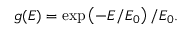Convert formula to latex. <formula><loc_0><loc_0><loc_500><loc_500>\begin{array} { r } { g ( E ) = \exp \left ( - E / E _ { 0 } \right ) / E _ { 0 } . } \end{array}</formula> 